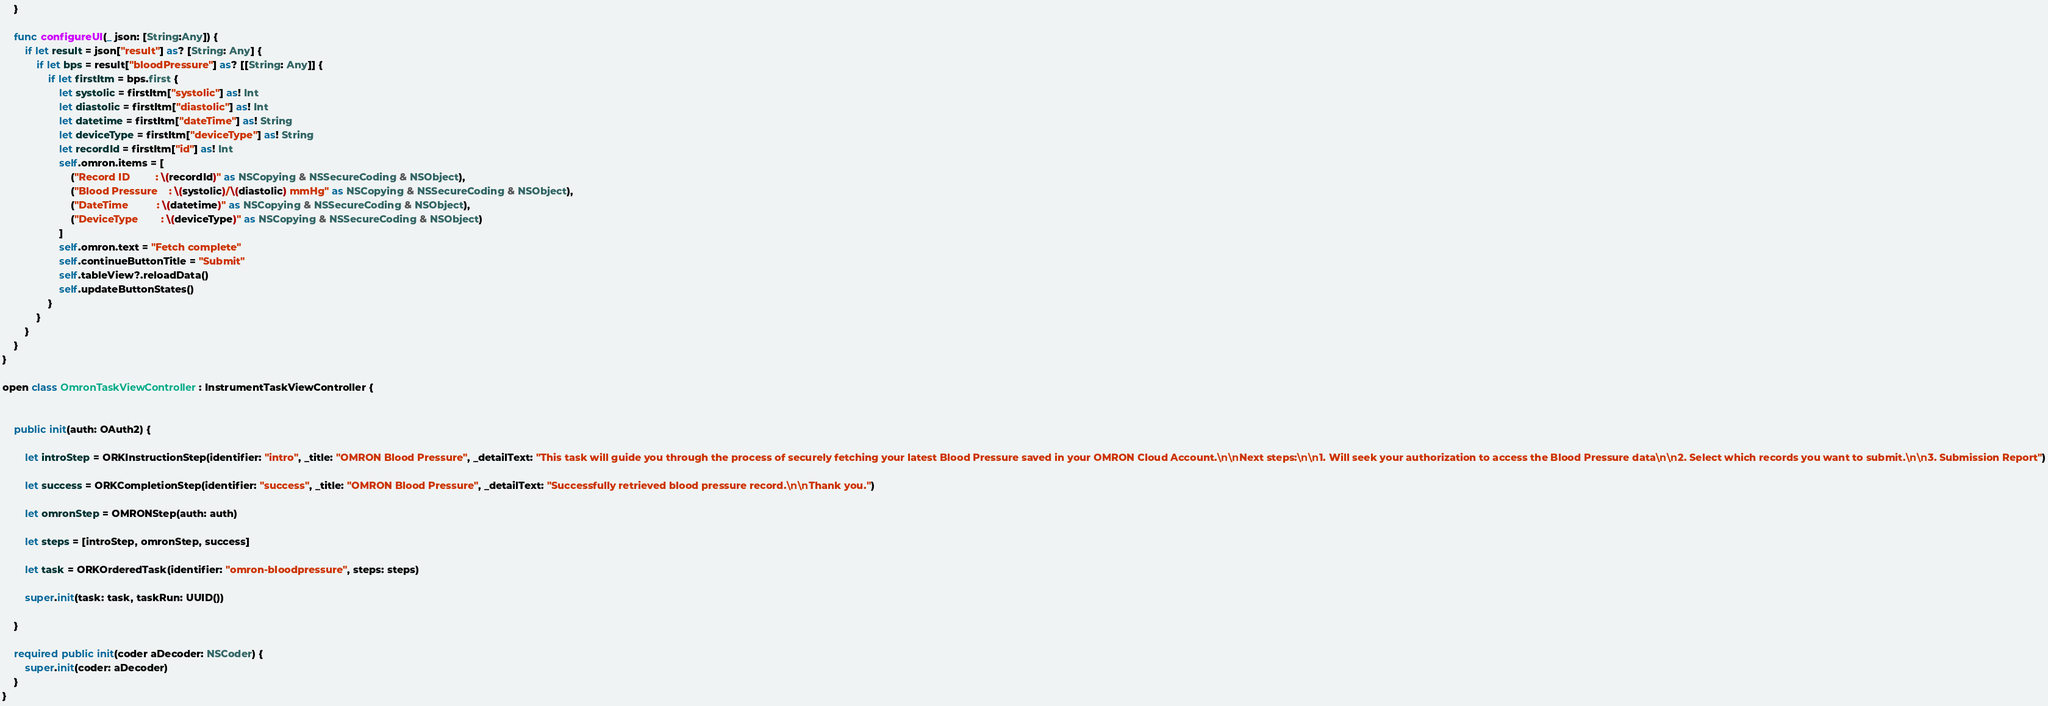<code> <loc_0><loc_0><loc_500><loc_500><_Swift_>    }
    
    func configureUI(_ json: [String:Any]) {
        if let result = json["result"] as? [String: Any] {
            if let bps = result["bloodPressure"] as? [[String: Any]] {
                if let firstItm = bps.first {
                    let systolic = firstItm["systolic"] as! Int
                    let diastolic = firstItm["diastolic"] as! Int
                    let datetime = firstItm["dateTime"] as! String
                    let deviceType = firstItm["deviceType"] as! String
                    let recordId = firstItm["id"] as! Int
                    self.omron.items = [
                        ("Record ID         : \(recordId)" as NSCopying & NSSecureCoding & NSObject),
                        ("Blood Pressure    : \(systolic)/\(diastolic) mmHg" as NSCopying & NSSecureCoding & NSObject),
                        ("DateTime          : \(datetime)" as NSCopying & NSSecureCoding & NSObject),
                        ("DeviceType        : \(deviceType)" as NSCopying & NSSecureCoding & NSObject)
                    ]
                    self.omron.text = "Fetch complete"
                    self.continueButtonTitle = "Submit"
					self.tableView?.reloadData()
                    self.updateButtonStates()
                }
            }
        }
    }
}

open class OmronTaskViewController: InstrumentTaskViewController {
    
    
    public init(auth: OAuth2) {
        
        let introStep = ORKInstructionStep(identifier: "intro", _title: "OMRON Blood Pressure", _detailText: "This task will guide you through the process of securely fetching your latest Blood Pressure saved in your OMRON Cloud Account.\n\nNext steps:\n\n1. Will seek your authorization to access the Blood Pressure data\n\n2. Select which records you want to submit.\n\n3. Submission Report")
        
        let success = ORKCompletionStep(identifier: "success", _title: "OMRON Blood Pressure", _detailText: "Successfully retrieved blood pressure record.\n\nThank you.")
        
        let omronStep = OMRONStep(auth: auth)
        
        let steps = [introStep, omronStep, success]
        
        let task = ORKOrderedTask(identifier: "omron-bloodpressure", steps: steps)
        
        super.init(task: task, taskRun: UUID())
        
    }
    
    required public init(coder aDecoder: NSCoder) {
        super.init(coder: aDecoder)
    }
}
</code> 